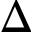Convert formula to latex. <formula><loc_0><loc_0><loc_500><loc_500>\Delta</formula> 